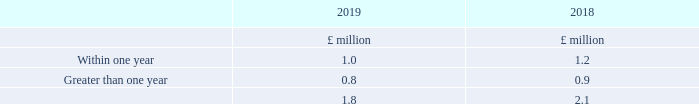Expected realisation of remaining performance obligations at year end
The Company applies the practical expedient in paragraph 121 of IFRS 15 and does not disclose information about remaining performance obligations that have original expected durations of one year or less.
For contracts that exceed one year, deferred income that relates to unsatisfied or partially satisfied performance obligations at year end is expected to be recognised as revenue in the future as follows:
The above information represents the revenue the Company will recognise when it satisfies the remaining performance obligations in the contracts. The amounts presented do not include orders for which neither party has performed.
Revenue from the sale of hardware and software generally arises from contracts less than one year in length. Consequently, the above amounts predominantly relate to the sale of maintenance and support services.
Virtually all of the revenue will be recognised within three years.
The Company provides standard warranties on its products and services. The nature of these warranties is considered to provide customers with assurance that the related product or service will function as intended in accordance with the agreed specification, and does not contain or imply any additional service obligation to the customer. Warranty obligations are estimated and recognised as liabilities based on the probable outflow of resources.
For contracts that exceed one year, what is expected to be recognised as revenue in the future? Deferred income that relates to unsatisfied or partially satisfied performance obligations at year end. What generally arises from contracts less than one year in length? Revenue from the sale of hardware and software. What are the types of contracts in the table for which the Company will recognise their revenue when it satisfies the remaining performance obligations in the contracts? Within one year, greater than one year. In which year was the amount within one year larger? 1.2>1.0
Answer: 2018. What was the change in the amount within one year between 2018 and 2019?
Answer scale should be: million. 1.0-1.2
Answer: -0.2. What was the percentage change in the amount within one year?
Answer scale should be: percent. (1.0-1.2)/1.2
Answer: -16.67. 